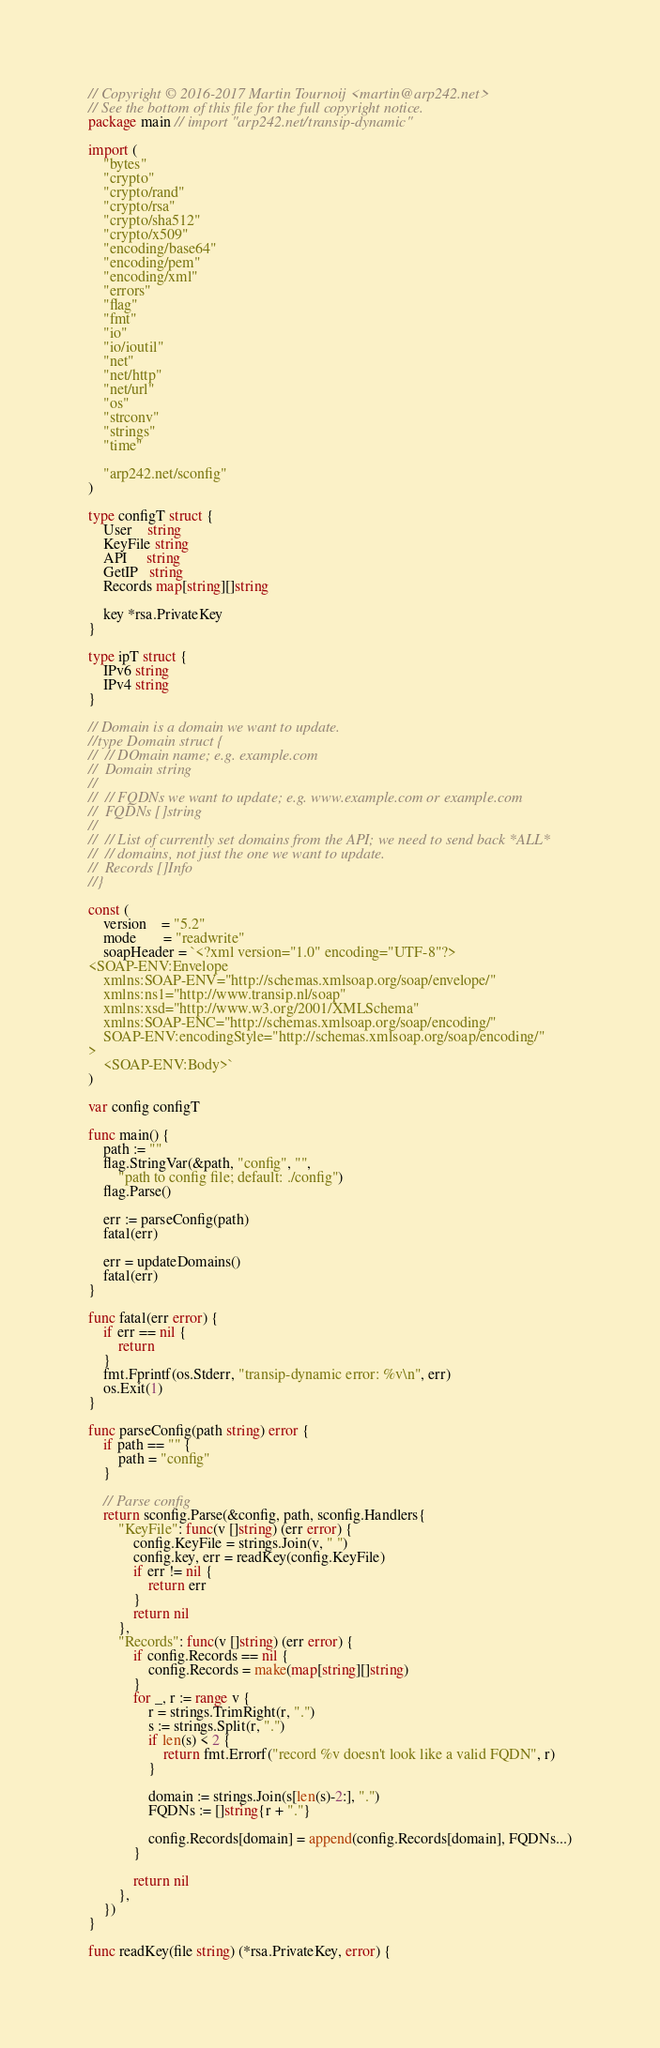<code> <loc_0><loc_0><loc_500><loc_500><_Go_>// Copyright © 2016-2017 Martin Tournoij <martin@arp242.net>
// See the bottom of this file for the full copyright notice.
package main // import "arp242.net/transip-dynamic"

import (
	"bytes"
	"crypto"
	"crypto/rand"
	"crypto/rsa"
	"crypto/sha512"
	"crypto/x509"
	"encoding/base64"
	"encoding/pem"
	"encoding/xml"
	"errors"
	"flag"
	"fmt"
	"io"
	"io/ioutil"
	"net"
	"net/http"
	"net/url"
	"os"
	"strconv"
	"strings"
	"time"

	"arp242.net/sconfig"
)

type configT struct {
	User    string
	KeyFile string
	API     string
	GetIP   string
	Records map[string][]string

	key *rsa.PrivateKey
}

type ipT struct {
	IPv6 string
	IPv4 string
}

// Domain is a domain we want to update.
//type Domain struct {
//	// DOmain name; e.g. example.com
//	Domain string
//
//	// FQDNs we want to update; e.g. www.example.com or example.com
//	FQDNs []string
//
//	// List of currently set domains from the API; we need to send back *ALL*
//	// domains, not just the one we want to update.
//	Records []Info
//}

const (
	version    = "5.2"
	mode       = "readwrite"
	soapHeader = `<?xml version="1.0" encoding="UTF-8"?>
<SOAP-ENV:Envelope
	xmlns:SOAP-ENV="http://schemas.xmlsoap.org/soap/envelope/"
	xmlns:ns1="http://www.transip.nl/soap"
	xmlns:xsd="http://www.w3.org/2001/XMLSchema"
	xmlns:SOAP-ENC="http://schemas.xmlsoap.org/soap/encoding/"
	SOAP-ENV:encodingStyle="http://schemas.xmlsoap.org/soap/encoding/"
>
	<SOAP-ENV:Body>`
)

var config configT

func main() {
	path := ""
	flag.StringVar(&path, "config", "",
		"path to config file; default: ./config")
	flag.Parse()

	err := parseConfig(path)
	fatal(err)

	err = updateDomains()
	fatal(err)
}

func fatal(err error) {
	if err == nil {
		return
	}
	fmt.Fprintf(os.Stderr, "transip-dynamic error: %v\n", err)
	os.Exit(1)
}

func parseConfig(path string) error {
	if path == "" {
		path = "config"
	}

	// Parse config
	return sconfig.Parse(&config, path, sconfig.Handlers{
		"KeyFile": func(v []string) (err error) {
			config.KeyFile = strings.Join(v, " ")
			config.key, err = readKey(config.KeyFile)
			if err != nil {
				return err
			}
			return nil
		},
		"Records": func(v []string) (err error) {
			if config.Records == nil {
				config.Records = make(map[string][]string)
			}
			for _, r := range v {
				r = strings.TrimRight(r, ".")
				s := strings.Split(r, ".")
				if len(s) < 2 {
					return fmt.Errorf("record %v doesn't look like a valid FQDN", r)
				}

				domain := strings.Join(s[len(s)-2:], ".")
				FQDNs := []string{r + "."}

				config.Records[domain] = append(config.Records[domain], FQDNs...)
			}

			return nil
		},
	})
}

func readKey(file string) (*rsa.PrivateKey, error) {</code> 